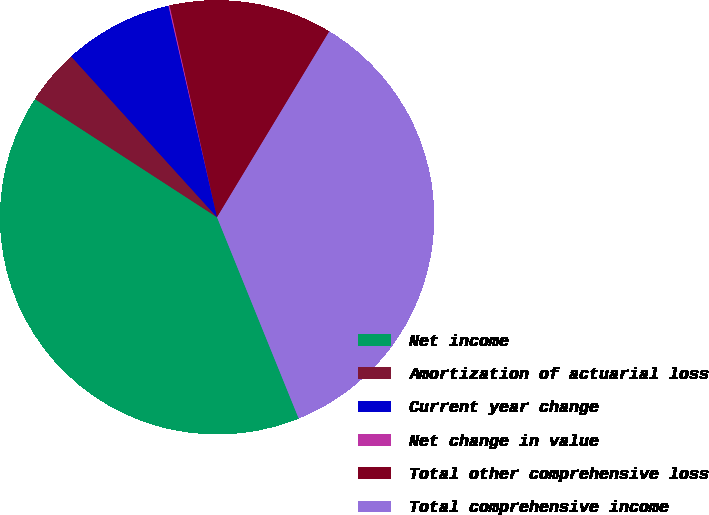Convert chart to OTSL. <chart><loc_0><loc_0><loc_500><loc_500><pie_chart><fcel>Net income<fcel>Amortization of actuarial loss<fcel>Current year change<fcel>Net change in value<fcel>Total other comprehensive loss<fcel>Total comprehensive income<nl><fcel>40.3%<fcel>4.11%<fcel>8.13%<fcel>0.09%<fcel>12.15%<fcel>35.22%<nl></chart> 